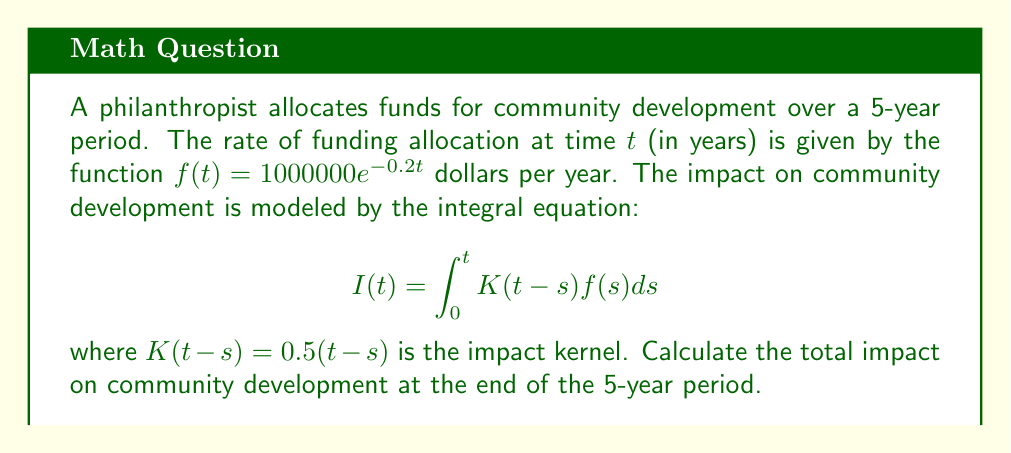Give your solution to this math problem. To solve this problem, we'll follow these steps:

1) First, we need to set up the integral equation:

   $$I(5) = \int_0^5 K(5-s)f(s)ds$$

2) Substitute the given functions:

   $$I(5) = \int_0^5 0.5(5-s)(1000000e^{-0.2s})ds$$

3) Simplify:

   $$I(5) = 500000 \int_0^5 (5-s)e^{-0.2s}ds$$

4) To solve this integral, we can use integration by parts. Let:
   $u = 5-s$, $du = -ds$
   $dv = e^{-0.2s}ds$, $v = -5e^{-0.2s}$

   $$I(5) = 500000 \left[ -5(5-s)e^{-0.2s} \Big|_0^5 + \int_0^5 5e^{-0.2s}ds \right]$$

5) Evaluate the first part:

   $$I(5) = 500000 \left[ 0 - (-25) + 25 \int_0^5 e^{-0.2s}ds \right]$$

6) Solve the remaining integral:

   $$I(5) = 500000 \left[ 25 - 125 \left[ -5e^{-0.2s} \right]_0^5 \right]$$

7) Evaluate:

   $$I(5) = 500000 \left[ 25 - 125(-5e^{-1} + 5) \right]$$

8) Simplify:

   $$I(5) = 500000(25 + 625e^{-1} - 625)$$
   $$I(5) = 12500000 + 312500000e^{-1} - 312500000$$
   $$I(5) = 312500000e^{-1} - 300000000$$

9) Calculate the final value:

   $$I(5) \approx 114,958,384.5244$$
Answer: $114,958,384.52$ (rounded to two decimal places) 